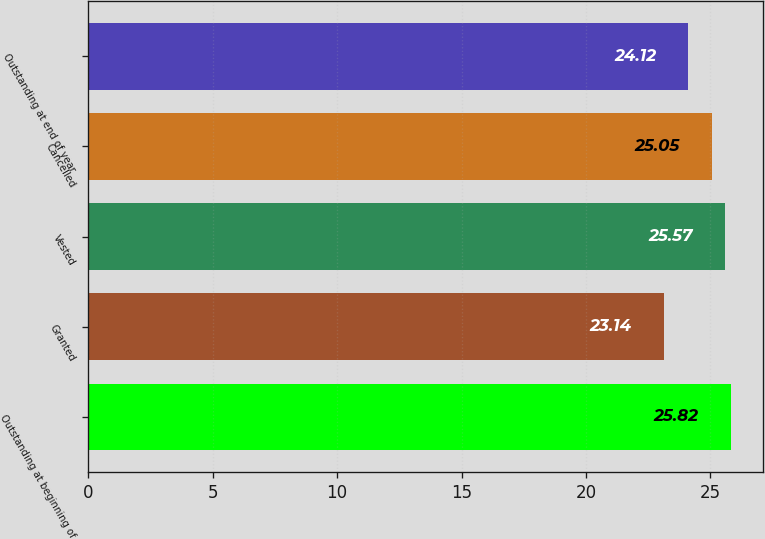Convert chart. <chart><loc_0><loc_0><loc_500><loc_500><bar_chart><fcel>Outstanding at beginning of<fcel>Granted<fcel>Vested<fcel>Cancelled<fcel>Outstanding at end of year<nl><fcel>25.82<fcel>23.14<fcel>25.57<fcel>25.05<fcel>24.12<nl></chart> 